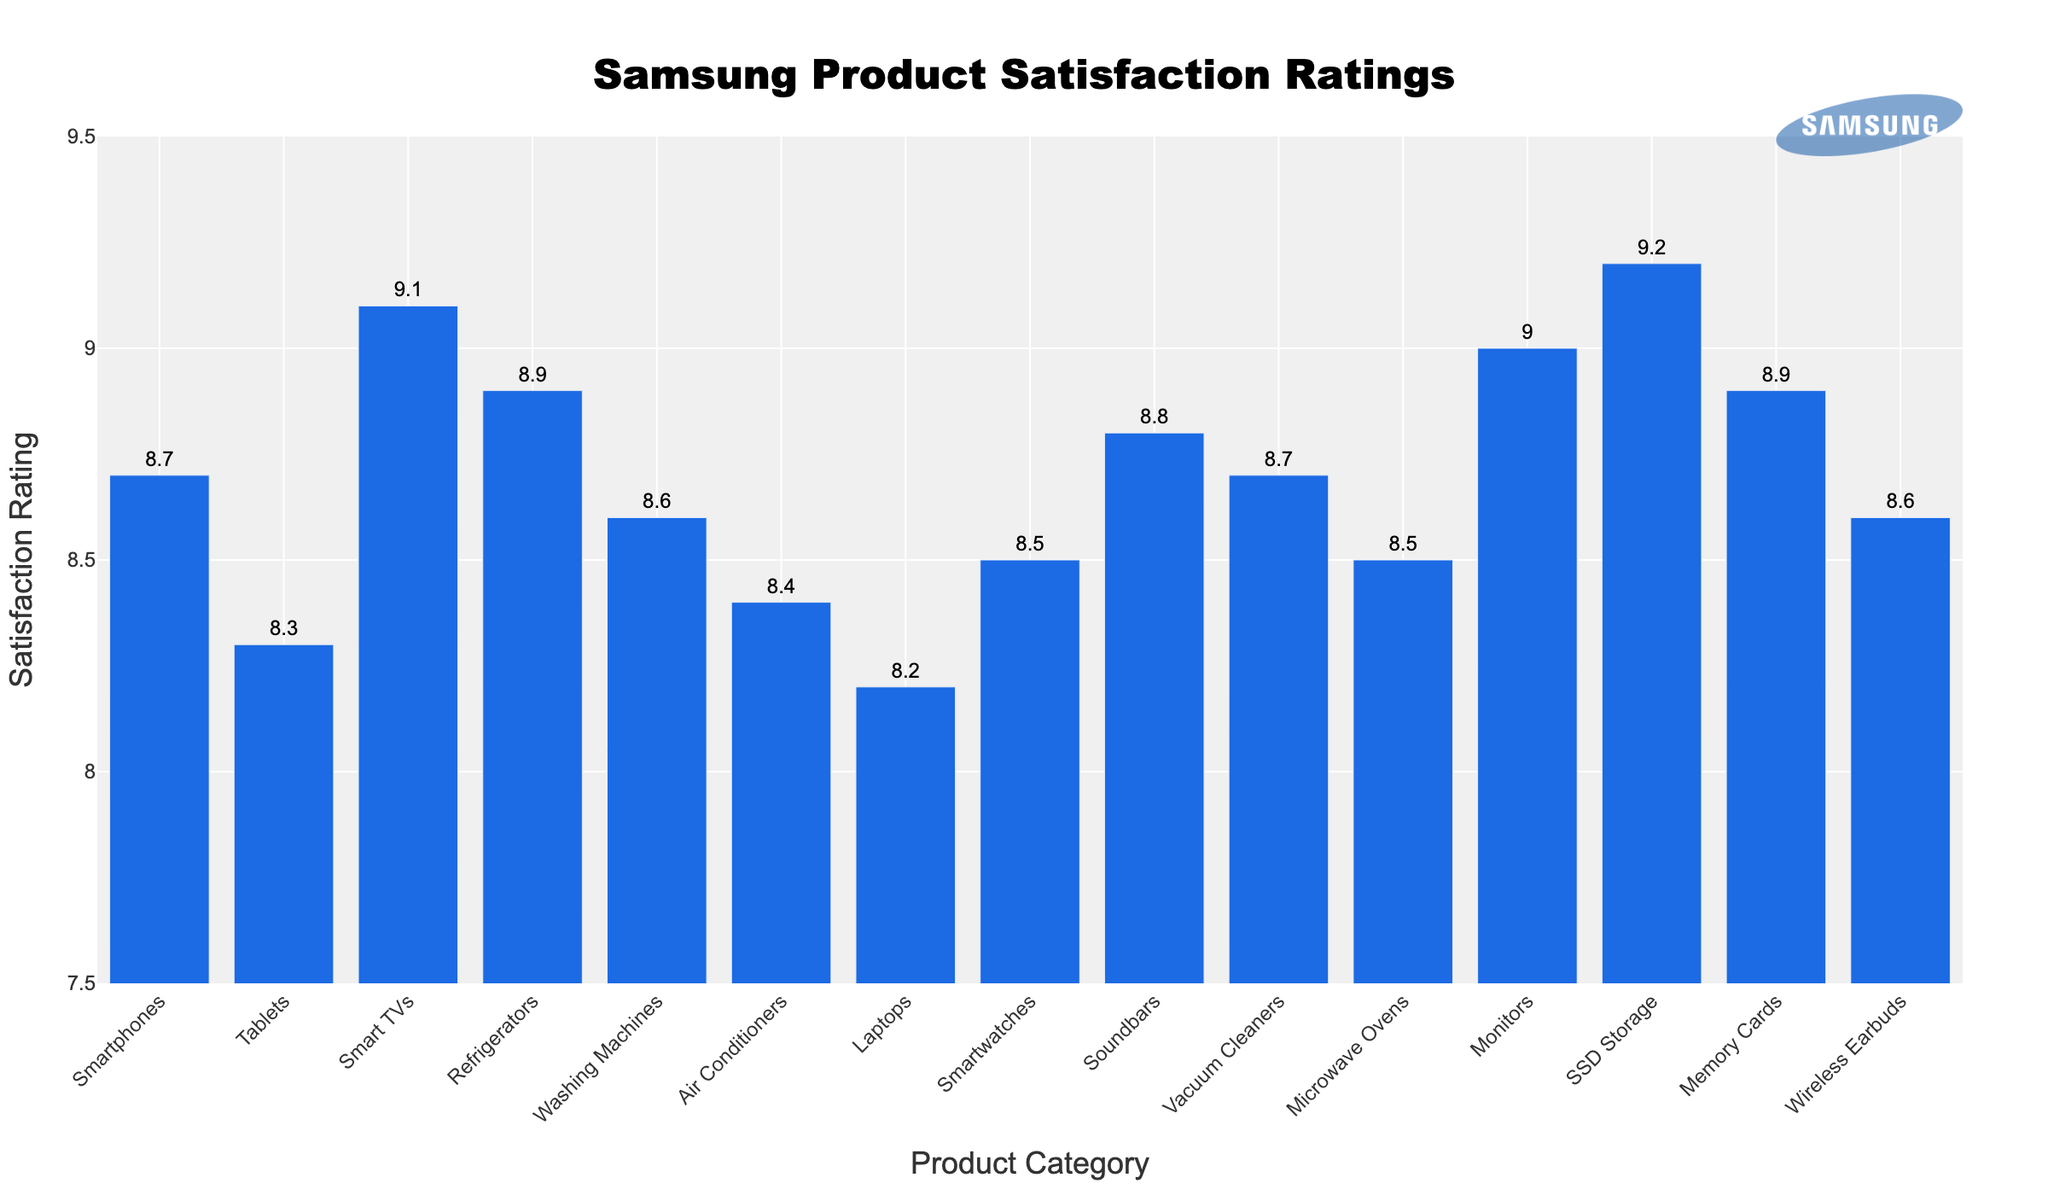Which product category has the highest customer satisfaction rating? By looking at the bar heights, the category with the highest bar represents the highest rating. In this case, SSD Storage has a rating of 9.2, which is the highest.
Answer: SSD Storage Which product category has the lowest customer satisfaction rating? The shortest bar corresponds to the lowest rating. Laptops have the lowest rating at 8.2.
Answer: Laptops What is the difference in customer satisfaction ratings between the highest and the lowest rated categories? The highest rating is 9.2 (SSD Storage) and the lowest is 8.2 (Laptops). The difference is calculated as 9.2 - 8.2 = 1.0.
Answer: 1.0 How many product categories have a satisfaction rating of 8.5 or higher? Count the number of bars that reach at least 8.5 on the Y-axis. There are Smartphones (8.7), Tablets (8.3), Smart TVs (9.1), Refrigerators (8.9), Washing Machines (8.6), Air Conditioners (8.4), Laptops (8.2), Smartwatches (8.5), Soundbars (8.8), Vacuum Cleaners (8.7), Microwave Ovens (8.5), Monitors (9.0), SSD Storage (9.2), Memory Cards (8.9), Wireless Earbuds (8.6). Out of these, 12 have 8.5 or higher.
Answer: 12 Which categories have customer satisfaction ratings equal to or above 9.0? Identify categories visually by noting the bar heights that reach or exceed the 9.0 mark. These are Smart TVs (9.1), Monitors (9.0), and SSD Storage (9.2).
Answer: Smart TVs, Monitors, SSD Storage What is the overall average customer satisfaction rating across all product categories? Sum up all the ratings and divide by the number of categories. The sum is 8.7 + 8.3 + 9.1 + 8.9 + 8.6 + 8.4 + 8.2 + 8.5 + 8.8 + 8.7 + 8.5 + 9.0 + 9.2 + 8.9 + 8.6 = 131.4. Dividing by 15 categories, the average is 131.4 / 15 = 8.76.
Answer: 8.76 Which product categories have the same customer satisfaction rating? Look for bars that are the same height. Both Smartphones and Vacuum Cleaners have a rating of 8.7; Washing Machines and Wireless Earbuds both have 8.6, and Microwave Ovens and Smartwatches both have 8.5.
Answer: Smartphones-Vacuum Cleaners, Washing Machines-Wireless Earbuds, Microwave Ovens-Smartwatches How much higher is the satisfaction rating of Smart TVs compared to Smartwatches? The satisfaction rating for Smart TVs is 9.1 and for Smartwatches is 8.5. Calculate the difference by subtracting 8.5 from 9.1, which is 9.1 - 8.5 = 0.6.
Answer: 0.6 What is the combined satisfaction rating for Tablets, Air Conditioners, and Laptops? Sum the satisfaction ratings for the specified categories: Tablets (8.3), Air Conditioners (8.4), and Laptops (8.2). The combined rating is 8.3 + 8.4 + 8.2 = 24.9.
Answer: 24.9 